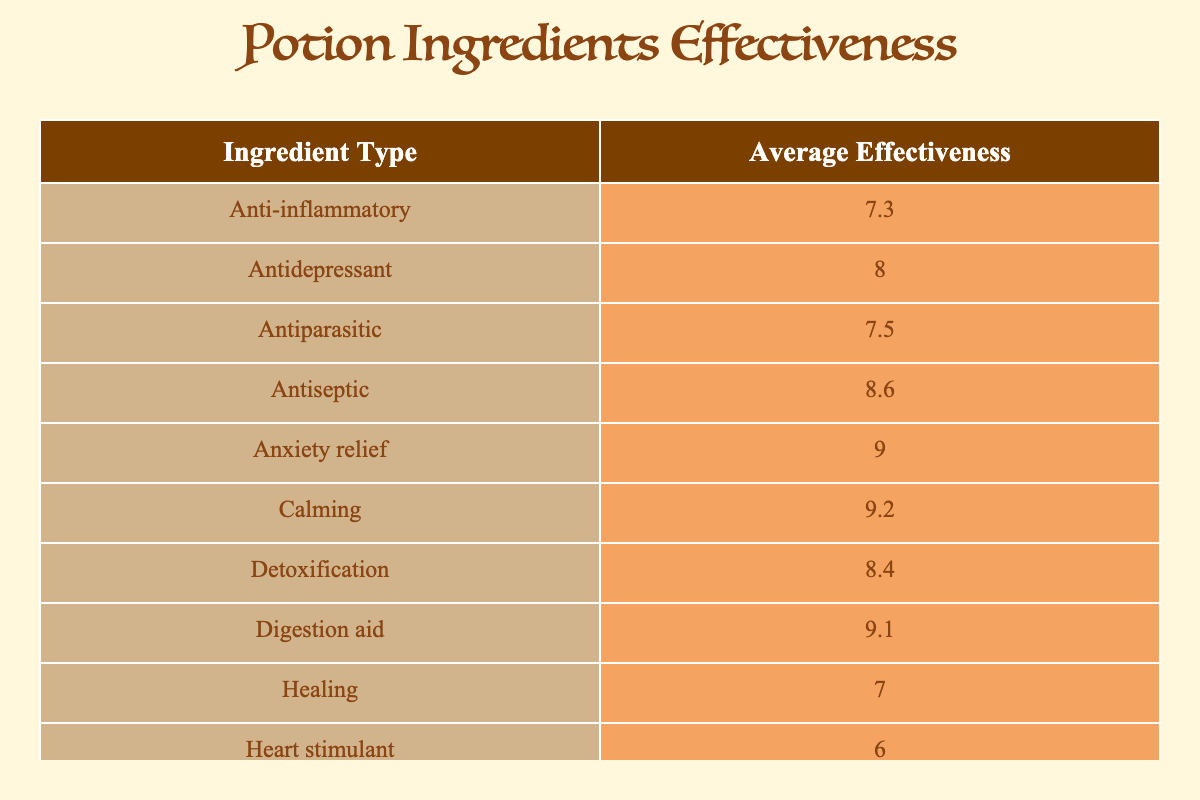What is the ingredient type with the highest average effectiveness rating? From the table, the "Nausea relief" ingredient, which is Ginger, has the highest average effectiveness rating of 9.5.
Answer: Nausea relief What is the average effectiveness rating for calming herbs? The calming herbs, Chamomile and Lavender, have ratings of 9.2 and 8.8 respectively. The average is calculated as (9.2 + 8.8) / 2 = 9.0.
Answer: 9.0 Is the average effectiveness rating for immune boosters higher than that for detoxification? The immune booster, Echinacea, has an effectiveness rating of 7.8, while the detoxification ingredient, Burdock root, has a rating of 8.4. Since 7.8 is not greater than 8.4, the answer is no.
Answer: No What is the effectiveness rating difference between the antiseptic and the anxiety relief ingredient? The antiseptic, Thyme, has a rating of 8.6, and the anxiety relief ingredient, Valerian, has a rating of 9.0. The difference is calculated as 9.0 - 8.6 = 0.4.
Answer: 0.4 Which ingredient type has the lowest average effectiveness rating? The heart stimulant ingredient Foxglove has the lowest average effectiveness rating of 6.0 according to the table.
Answer: Heart stimulant What is the total average effectiveness rating for all the ingredients listed? We calculate the total average by summing up all the effectiveness ratings: (8.5 + 7.0 + 9.2 + 6.0 + 7.5 + 8.0 + 9.0 + 8.8 + 7.8 + 9.5 + 8.4 + 9.1 + 7.3 + 8.6 + 7.9 + 9.3) = 140.7 and dividing by the total of 16 ingredients gives an average of 140.7 / 16 = 8.79.
Answer: 8.79 Is there any healing ingredient with a rating above 8? The healing ingredient Mandrake has a rating of 7.0, which is not above 8, considering the other types, the answer is no.
Answer: No What are the two types of ingredients that have average effectiveness ratings of 8.0 or higher? In the table, there are six types with ratings of 8.0 and above: Calming, Anxiety relief, Wound healing, Detoxification, Digestion aid, and Relaxation.
Answer: Calming and Anxiety relief What is the average effectiveness rating for the toxin ingredients compared to the others? The only toxin listed is Aconite with a rating of 8.5, while the average for all other types (excluding toxins) is calculated as (7.0 + 9.2 + 6.0 + 7.5 + 8.0 + 9.0 + 8.8 + 7.8 + 9.5 + 8.4 + 9.1 + 7.3 + 8.6 + 7.9 + 9.3) / 15 = 8.15. Comparing 8.5 and 8.15 shows that the toxin ingredient is indeed higher.
Answer: Yes 